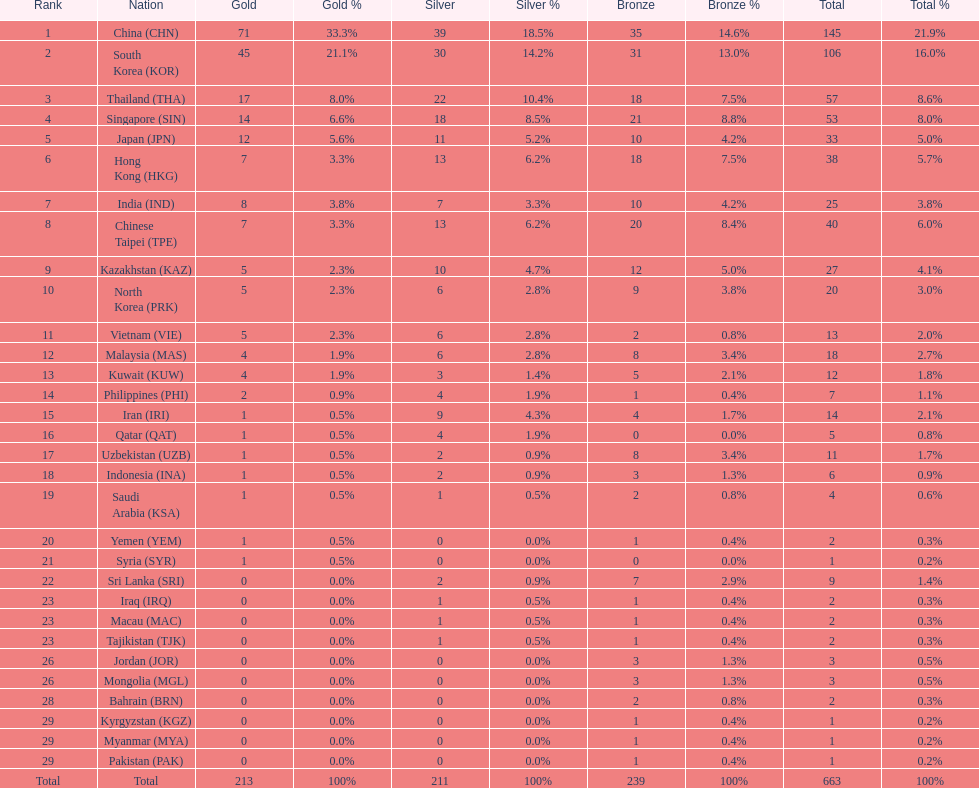What were the number of medals iran earned? 14. 